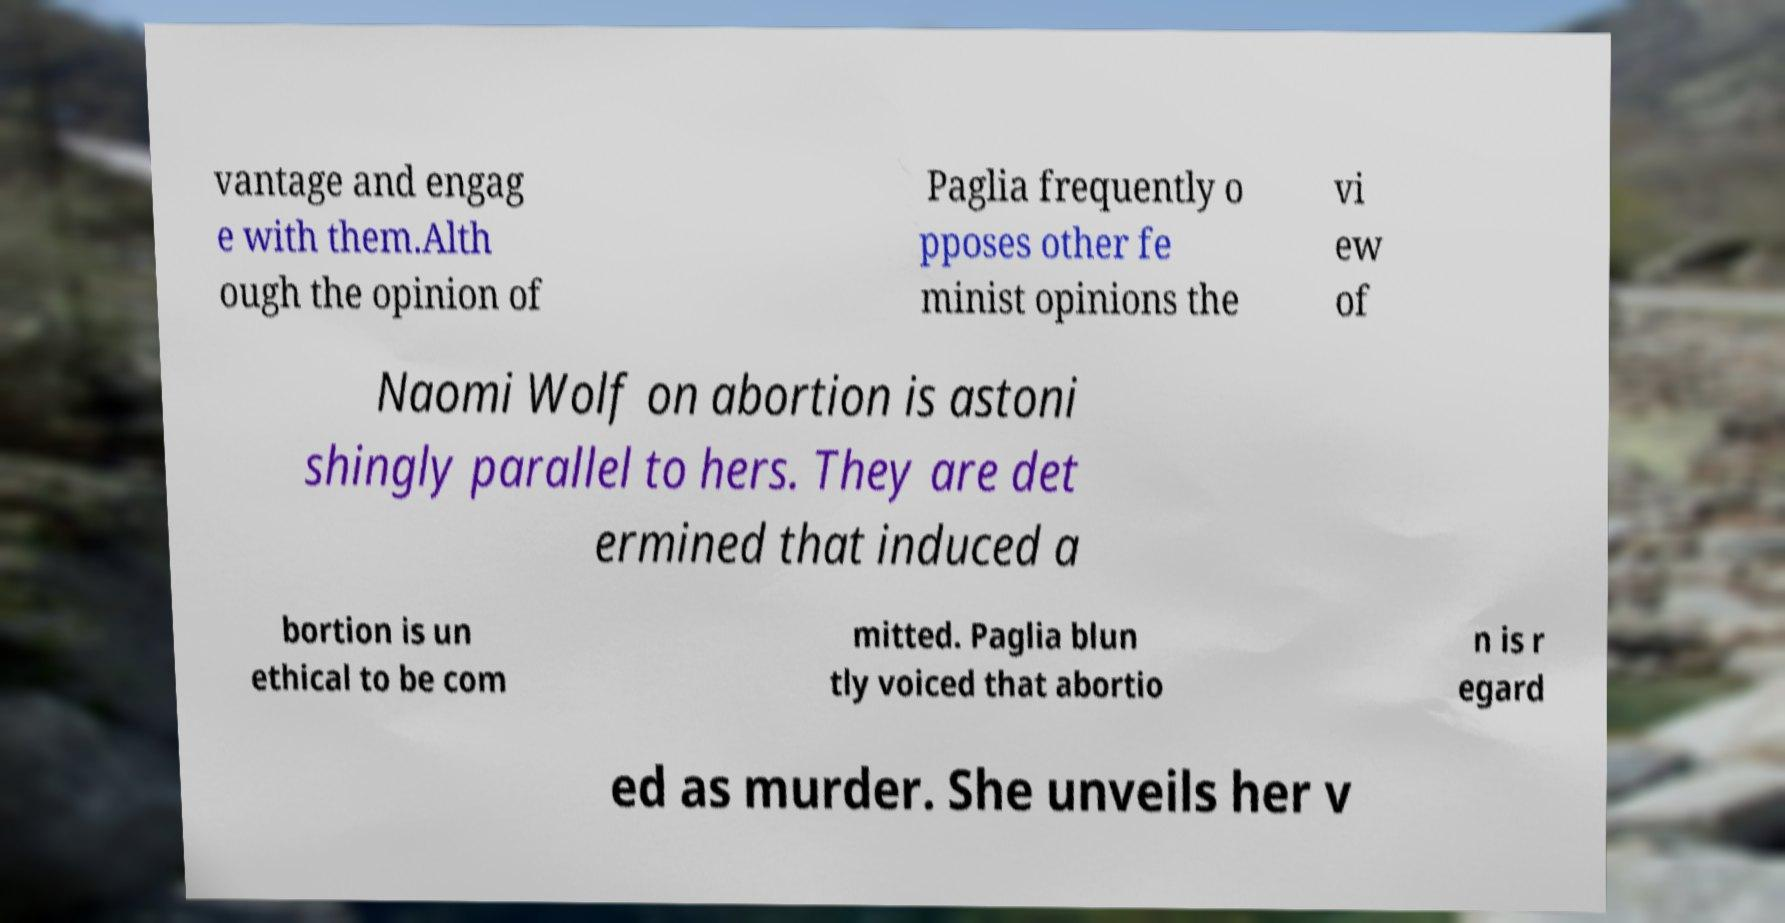Please read and relay the text visible in this image. What does it say? vantage and engag e with them.Alth ough the opinion of Paglia frequently o pposes other fe minist opinions the vi ew of Naomi Wolf on abortion is astoni shingly parallel to hers. They are det ermined that induced a bortion is un ethical to be com mitted. Paglia blun tly voiced that abortio n is r egard ed as murder. She unveils her v 